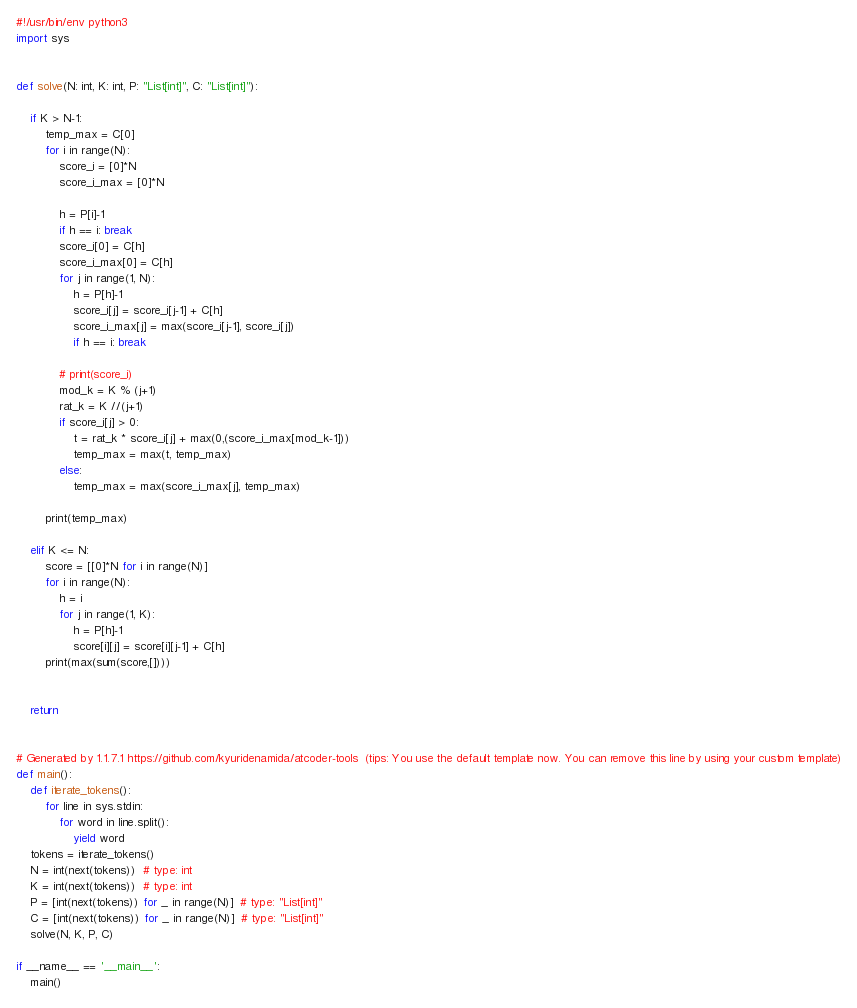<code> <loc_0><loc_0><loc_500><loc_500><_Python_>#!/usr/bin/env python3
import sys


def solve(N: int, K: int, P: "List[int]", C: "List[int]"):

    if K > N-1:
        temp_max = C[0]
        for i in range(N):
            score_i = [0]*N 
            score_i_max = [0]*N

            h = P[i]-1
            if h == i: break
            score_i[0] = C[h]
            score_i_max[0] = C[h]
            for j in range(1, N):
                h = P[h]-1
                score_i[j] = score_i[j-1] + C[h]
                score_i_max[j] = max(score_i[j-1], score_i[j])
                if h == i: break

            # print(score_i)
            mod_k = K % (j+1)
            rat_k = K //(j+1)
            if score_i[j] > 0:
                t = rat_k * score_i[j] + max(0,(score_i_max[mod_k-1]))
                temp_max = max(t, temp_max)
            else:
                temp_max = max(score_i_max[j], temp_max)

        print(temp_max)
    
    elif K <= N:
        score = [[0]*N for i in range(N)]
        for i in range(N):
            h = i
            for j in range(1, K):
                h = P[h]-1
                score[i][j] = score[i][j-1] + C[h]
        print(max(sum(score,[])))


    return


# Generated by 1.1.7.1 https://github.com/kyuridenamida/atcoder-tools  (tips: You use the default template now. You can remove this line by using your custom template)
def main():
    def iterate_tokens():
        for line in sys.stdin:
            for word in line.split():
                yield word
    tokens = iterate_tokens()
    N = int(next(tokens))  # type: int
    K = int(next(tokens))  # type: int
    P = [int(next(tokens)) for _ in range(N)]  # type: "List[int]"
    C = [int(next(tokens)) for _ in range(N)]  # type: "List[int]"
    solve(N, K, P, C)

if __name__ == '__main__':
    main()
</code> 